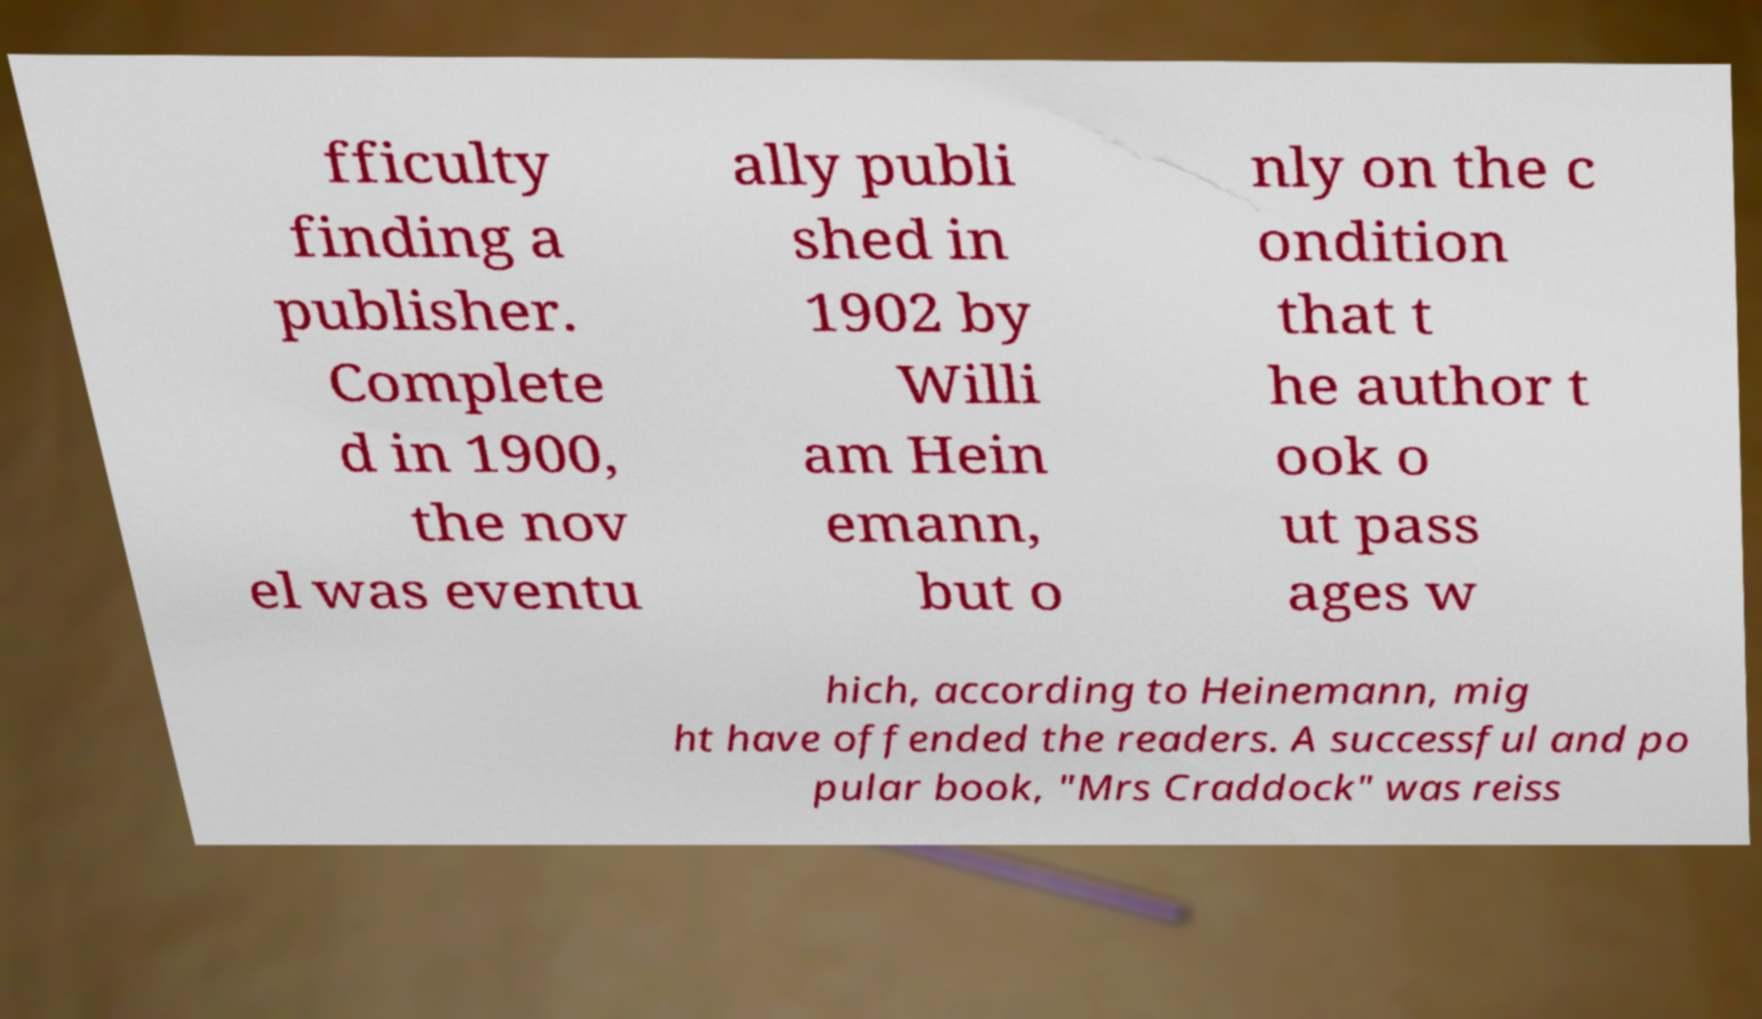What messages or text are displayed in this image? I need them in a readable, typed format. fficulty finding a publisher. Complete d in 1900, the nov el was eventu ally publi shed in 1902 by Willi am Hein emann, but o nly on the c ondition that t he author t ook o ut pass ages w hich, according to Heinemann, mig ht have offended the readers. A successful and po pular book, "Mrs Craddock" was reiss 